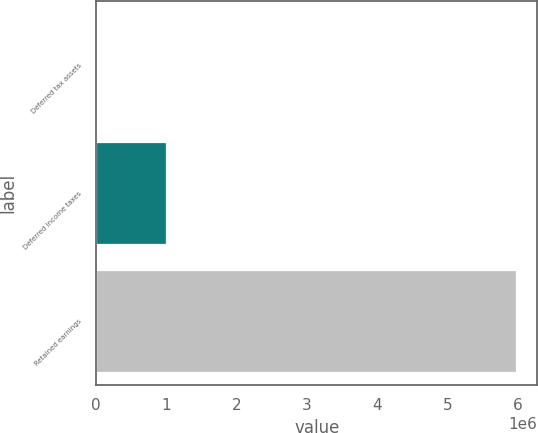Convert chart. <chart><loc_0><loc_0><loc_500><loc_500><bar_chart><fcel>Deferred tax assets<fcel>Deferred income taxes<fcel>Retained earnings<nl><fcel>9665<fcel>990409<fcel>5.9827e+06<nl></chart> 